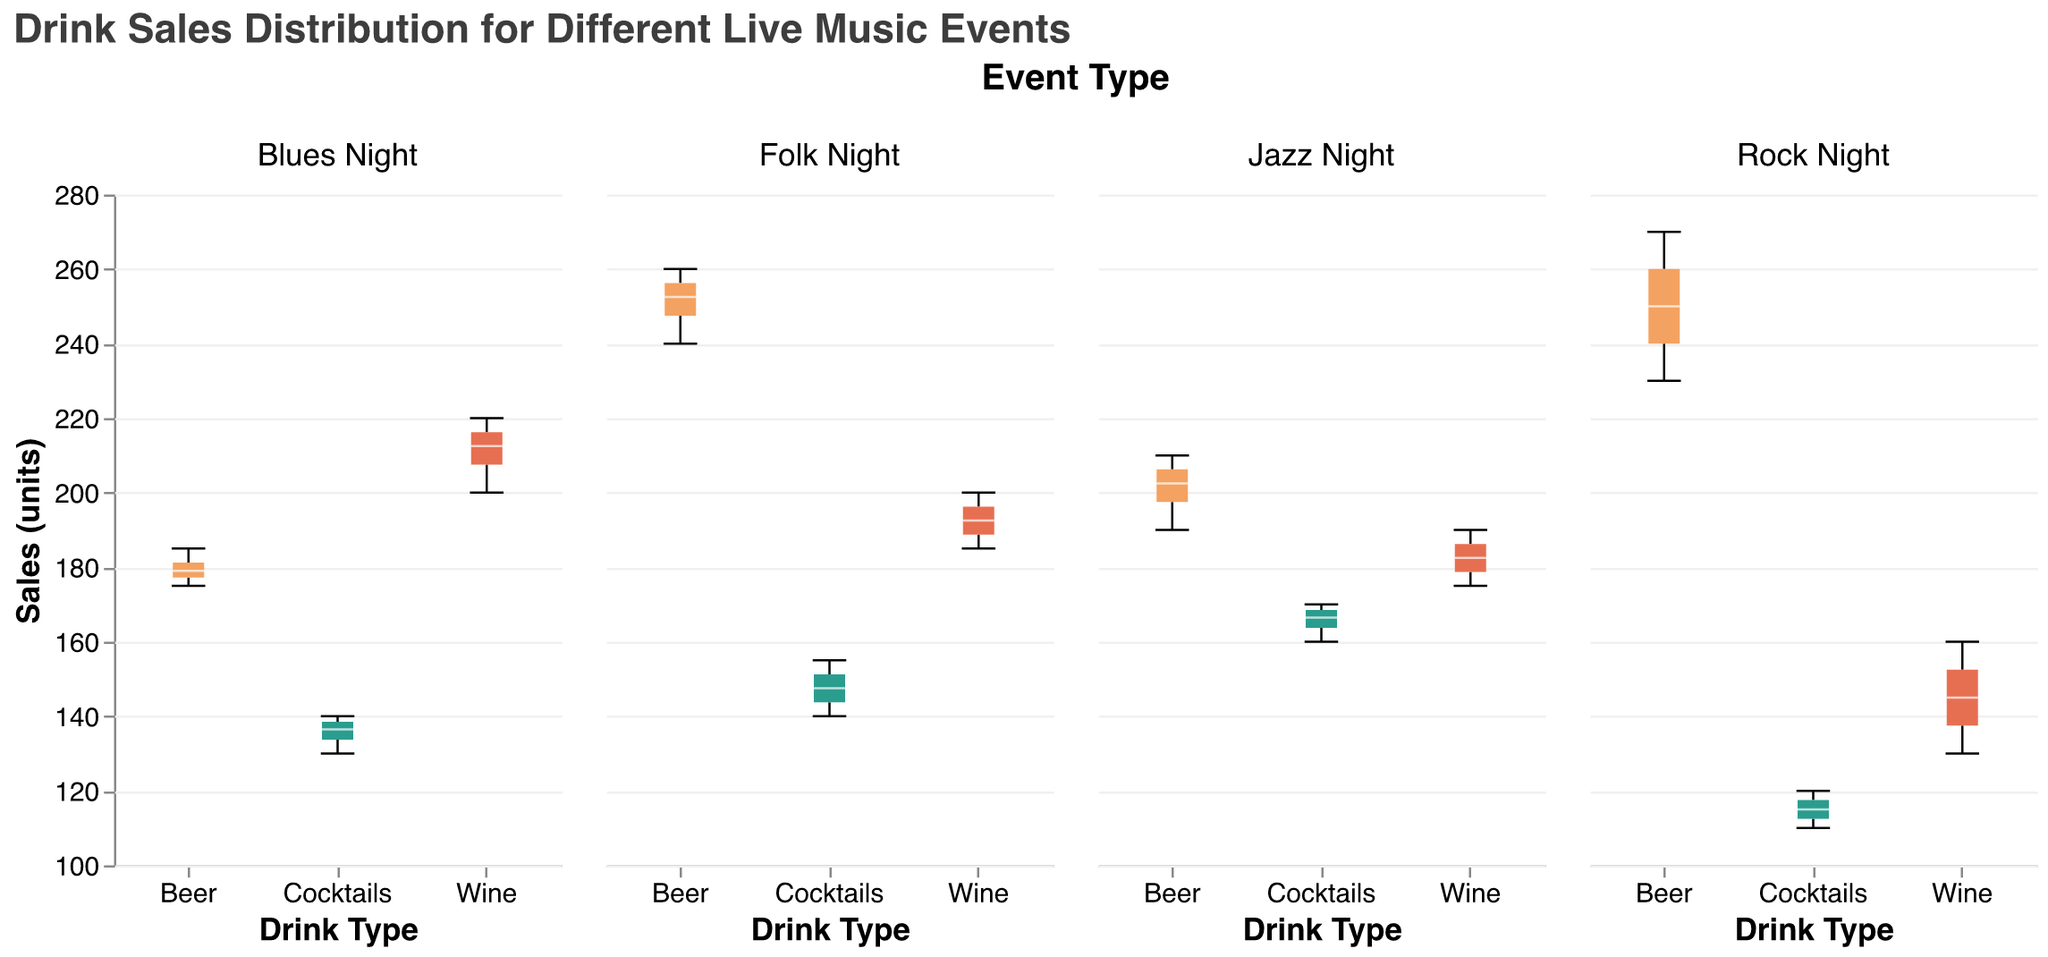How many drink types are displayed in the figure? Look at the x-axis labels for each subplot, which show the type of drinks analyzed: Beer, Wine, and Cocktails.
Answer: Three Which event type has the highest median drink sales for Beer? Observe the median line inside the box plot for Beer across all subplots. Folk Night has the highest position for the median line.
Answer: Folk Night What is the range of Beer sales during Rock Night? Look at the extent of the whiskers for the Beer box plot in the Rock Night subplot. The minimum is 230 and the maximum is 270. The range is the difference between these values.
Answer: 40 Compare the median Wine sales between Blues Night and Jazz Night. Which one is higher? Look at the median lines in the box plots for Wine in both Blues Night and Jazz Night subplots. The median line is higher in Blues Night.
Answer: Blues Night What is the interquartile range (IQR) for Cocktail sales during Jazz Night? The IQR is found by subtracting the lower quartile (lower edge of the box) from the upper quartile (upper edge of the box) in the Cocktails box plot for Jazz Night.
Answer: 10 Which event shows the greatest variation in Beer sales? The variation can be assessed by observing the length of the whiskers in the Beer box plots for all events. Rock Night has the longest whiskers for Beer, indicating the greatest variation.
Answer: Rock Night Are the median sales for Wine during Rock Night greater than those during Folk Night? Compare the median lines in the Wine box plots for Rock Night and Folk Night. The median line for Rock Night is below that for Folk Night.
Answer: No What is the median sales value for Cocktails during Blues Night? Identify the median line within the Cocktails box plot for Blues Night and read the corresponding value.
Answer: 135 Which drink type has the lowest median sales across all event types? Compare the median lines for each drink type across all subplots. Cocktails generally have the lowest median sales values.
Answer: Cocktails How does the median sales of Wine during Folk Night compare to Beer sales during Jazz Night? Observe the median lines in the Wine box plot for Folk Night and the Beer box plot for Jazz Night. Folk Night's Wine has a higher median than Jazz Night's Beer.
Answer: Higher 